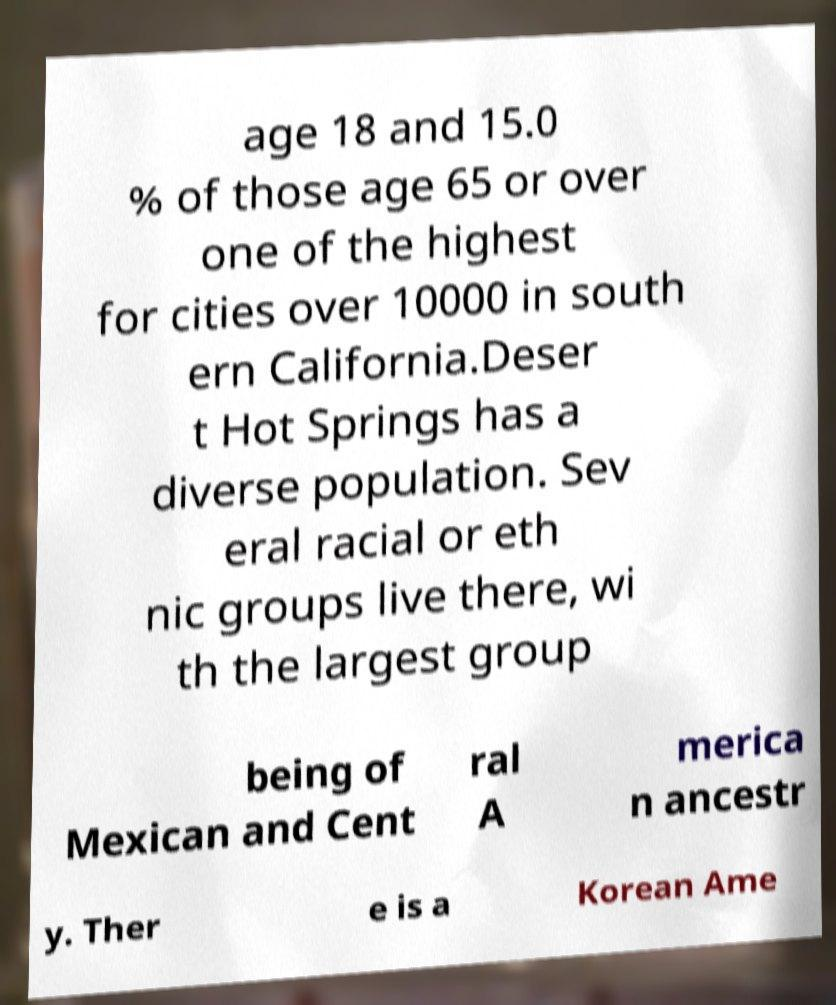Please identify and transcribe the text found in this image. age 18 and 15.0 % of those age 65 or over one of the highest for cities over 10000 in south ern California.Deser t Hot Springs has a diverse population. Sev eral racial or eth nic groups live there, wi th the largest group being of Mexican and Cent ral A merica n ancestr y. Ther e is a Korean Ame 